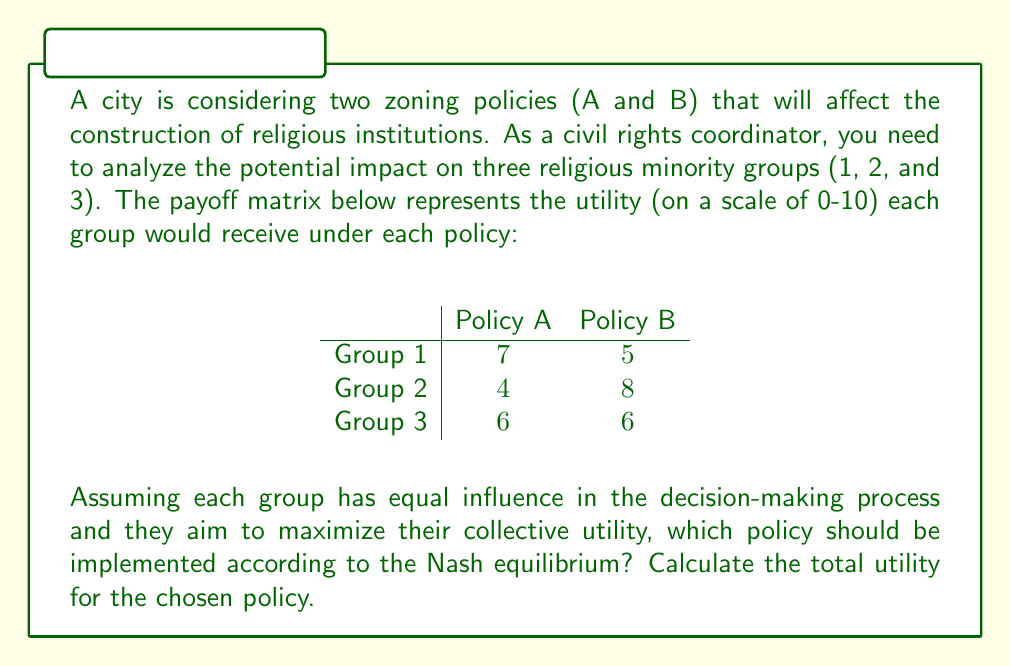Could you help me with this problem? To solve this problem, we need to analyze the game using Nash equilibrium concepts:

1) First, we need to calculate the total utility for each policy:

   Policy A: $7 + 4 + 6 = 17$
   Policy B: $5 + 8 + 6 = 19$

2) In this case, we have a pure strategy Nash equilibrium. Since all groups have equal influence and aim to maximize collective utility, they will choose the policy that gives the highest total utility.

3) Policy B provides a higher total utility (19) compared to Policy A (17).

4) This is a Nash equilibrium because no single group can unilaterally change their decision to improve their outcome:
   - If Group 1 alone opposes Policy B, it won't change the outcome.
   - Group 2 and 3 have no incentive to change their preference from B to A.

5) Therefore, Policy B is the Nash equilibrium solution.

6) The total utility for the chosen policy (B) is 19.
Answer: Policy B should be implemented according to the Nash equilibrium, with a total utility of 19. 